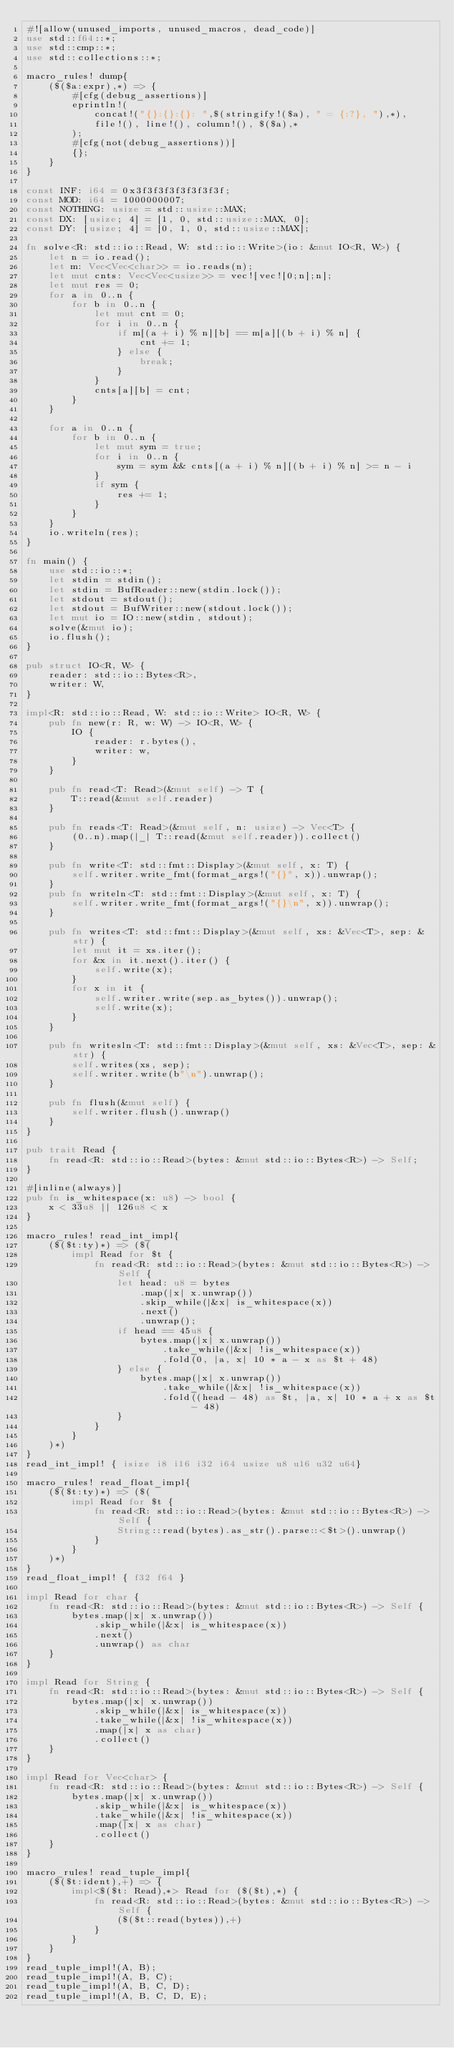<code> <loc_0><loc_0><loc_500><loc_500><_Rust_>#![allow(unused_imports, unused_macros, dead_code)]
use std::f64::*;
use std::cmp::*;
use std::collections::*;

macro_rules! dump{
    ($($a:expr),*) => {
        #[cfg(debug_assertions)]
        eprintln!(
            concat!("{}:{}:{}: ",$(stringify!($a), " = {:?}, "),*),
            file!(), line!(), column!(), $($a),*
        );
        #[cfg(not(debug_assertions))]
        {};
    }
}

const INF: i64 = 0x3f3f3f3f3f3f3f3f;
const MOD: i64 = 1000000007;
const NOTHING: usize = std::usize::MAX;
const DX: [usize; 4] = [1, 0, std::usize::MAX, 0];
const DY: [usize; 4] = [0, 1, 0, std::usize::MAX];

fn solve<R: std::io::Read, W: std::io::Write>(io: &mut IO<R, W>) {
    let n = io.read();
    let m: Vec<Vec<char>> = io.reads(n);
    let mut cnts: Vec<Vec<usize>> = vec![vec![0;n];n];
    let mut res = 0;
    for a in 0..n {
        for b in 0..n {
            let mut cnt = 0;
            for i in 0..n {
                if m[(a + i) % n][b] == m[a][(b + i) % n] {
                    cnt += 1;
                } else {
                    break;
                }
            }
            cnts[a][b] = cnt;
        }
    }

    for a in 0..n {
        for b in 0..n {
            let mut sym = true;
            for i in 0..n {
                sym = sym && cnts[(a + i) % n][(b + i) % n] >= n - i
            }
            if sym {
                res += 1;
            }
        }
    }
    io.writeln(res);
}

fn main() {
    use std::io::*;
    let stdin = stdin();
    let stdin = BufReader::new(stdin.lock());
    let stdout = stdout();
    let stdout = BufWriter::new(stdout.lock());
    let mut io = IO::new(stdin, stdout);
    solve(&mut io);
    io.flush();
}

pub struct IO<R, W> {
    reader: std::io::Bytes<R>,
    writer: W,
}

impl<R: std::io::Read, W: std::io::Write> IO<R, W> {
    pub fn new(r: R, w: W) -> IO<R, W> {
        IO {
            reader: r.bytes(),
            writer: w,
        }
    }

    pub fn read<T: Read>(&mut self) -> T {
        T::read(&mut self.reader)
    }

    pub fn reads<T: Read>(&mut self, n: usize) -> Vec<T> {
        (0..n).map(|_| T::read(&mut self.reader)).collect()
    }

    pub fn write<T: std::fmt::Display>(&mut self, x: T) {
        self.writer.write_fmt(format_args!("{}", x)).unwrap();
    }
    pub fn writeln<T: std::fmt::Display>(&mut self, x: T) {
        self.writer.write_fmt(format_args!("{}\n", x)).unwrap();
    }

    pub fn writes<T: std::fmt::Display>(&mut self, xs: &Vec<T>, sep: &str) {
        let mut it = xs.iter();
        for &x in it.next().iter() {
            self.write(x);
        }
        for x in it {
            self.writer.write(sep.as_bytes()).unwrap();
            self.write(x);
        }
    }

    pub fn writesln<T: std::fmt::Display>(&mut self, xs: &Vec<T>, sep: &str) {
        self.writes(xs, sep);
        self.writer.write(b"\n").unwrap();
    }

    pub fn flush(&mut self) {
        self.writer.flush().unwrap()
    }
}

pub trait Read {
    fn read<R: std::io::Read>(bytes: &mut std::io::Bytes<R>) -> Self;
}

#[inline(always)]
pub fn is_whitespace(x: u8) -> bool {
    x < 33u8 || 126u8 < x
}

macro_rules! read_int_impl{
    ($($t:ty)*) => ($(
        impl Read for $t {
            fn read<R: std::io::Read>(bytes: &mut std::io::Bytes<R>) -> Self {
                let head: u8 = bytes
                    .map(|x| x.unwrap())
                    .skip_while(|&x| is_whitespace(x))
                    .next()
                    .unwrap();
                if head == 45u8 {
                    bytes.map(|x| x.unwrap())
                        .take_while(|&x| !is_whitespace(x))
                        .fold(0, |a, x| 10 * a - x as $t + 48)
                } else {
                    bytes.map(|x| x.unwrap())
                        .take_while(|&x| !is_whitespace(x))
                        .fold((head - 48) as $t, |a, x| 10 * a + x as $t - 48)
                }
            }
        }
    )*)
}
read_int_impl! { isize i8 i16 i32 i64 usize u8 u16 u32 u64}

macro_rules! read_float_impl{
    ($($t:ty)*) => ($(
        impl Read for $t {
            fn read<R: std::io::Read>(bytes: &mut std::io::Bytes<R>) -> Self {
                String::read(bytes).as_str().parse::<$t>().unwrap()
            }
        }
    )*)
}
read_float_impl! { f32 f64 }

impl Read for char {
    fn read<R: std::io::Read>(bytes: &mut std::io::Bytes<R>) -> Self {
        bytes.map(|x| x.unwrap())
            .skip_while(|&x| is_whitespace(x))
            .next()
            .unwrap() as char
    }
}

impl Read for String {
    fn read<R: std::io::Read>(bytes: &mut std::io::Bytes<R>) -> Self {
        bytes.map(|x| x.unwrap())
            .skip_while(|&x| is_whitespace(x))
            .take_while(|&x| !is_whitespace(x))
            .map(|x| x as char)
            .collect()
    }
}

impl Read for Vec<char> {
    fn read<R: std::io::Read>(bytes: &mut std::io::Bytes<R>) -> Self {
        bytes.map(|x| x.unwrap())
            .skip_while(|&x| is_whitespace(x))
            .take_while(|&x| !is_whitespace(x))
            .map(|x| x as char)
            .collect()
    }
}

macro_rules! read_tuple_impl{
    ($($t:ident),+) => {
        impl<$($t: Read),*> Read for ($($t),*) {
            fn read<R: std::io::Read>(bytes: &mut std::io::Bytes<R>) -> Self {
                ($($t::read(bytes)),+)
            }
        }
    }
}
read_tuple_impl!(A, B);
read_tuple_impl!(A, B, C);
read_tuple_impl!(A, B, C, D);
read_tuple_impl!(A, B, C, D, E);
</code> 